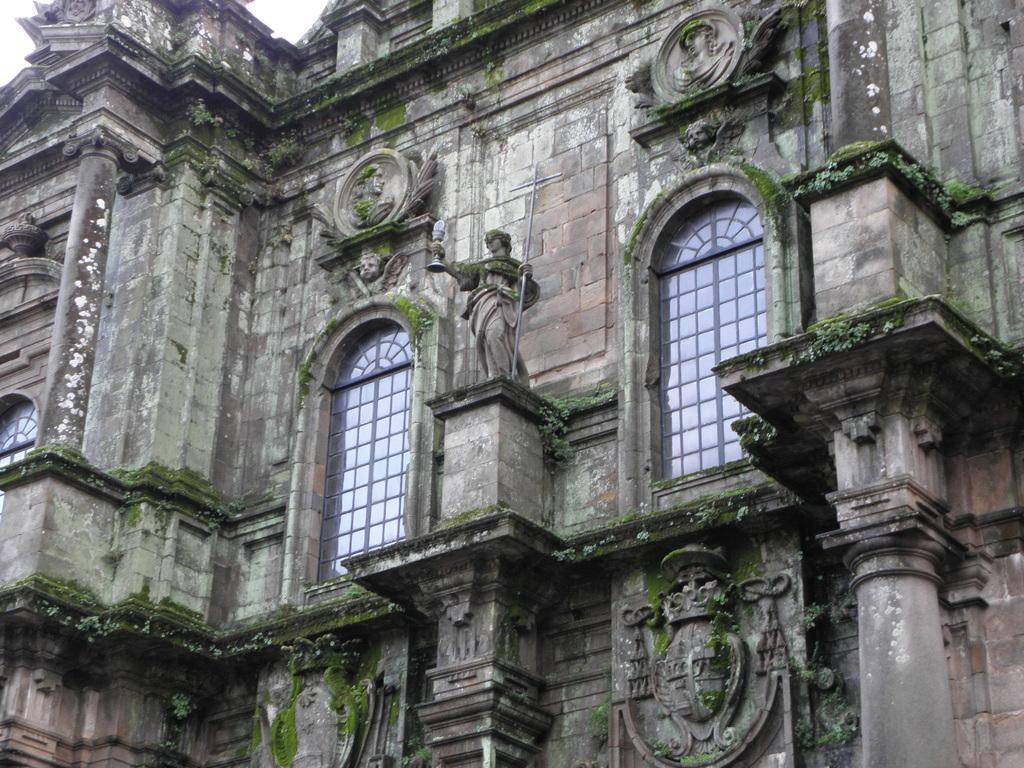Describe this image in one or two sentences. In this picture I can see the palace. I can see glass windows. 